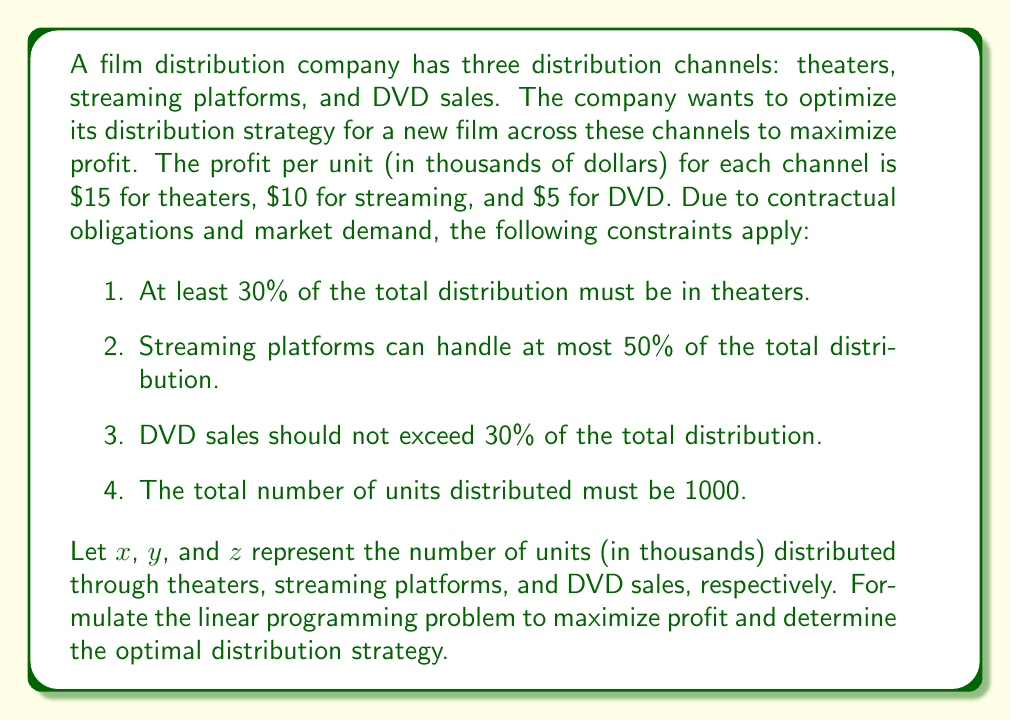Solve this math problem. To solve this problem, we need to set up the linear programming model and then solve it. Let's go through this step-by-step:

1. Define the objective function:
   We want to maximize profit, so our objective function is:
   $$\text{Maximize } P = 15x + 10y + 5z$$

2. Set up the constraints:
   a) Theater constraint: $x \geq 0.3(x + y + z)$
   b) Streaming constraint: $y \leq 0.5(x + y + z)$
   c) DVD constraint: $z \leq 0.3(x + y + z)$
   d) Total distribution: $x + y + z = 1$

3. Simplify the constraints:
   a) $0.7x - 0.3y - 0.3z \geq 0$
   b) $-0.5x + 0.5y - 0.5z \leq 0$
   c) $-0.3x - 0.3y + 0.7z \leq 0$
   d) $x + y + z = 1$

4. Solve the linear programming problem:
   We can solve this using the simplex method or linear programming software. The optimal solution is:
   $x = 0.5$, $y = 0.3$, $z = 0.2$

5. Interpret the results:
   The optimal distribution strategy is:
   - Theaters: 500 units (50%)
   - Streaming platforms: 300 units (30%)
   - DVD sales: 200 units (20%)

6. Calculate the maximum profit:
   $$P = 15(0.5) + 10(0.3) + 5(0.2) = 7.5 + 3 + 1 = 11.5$$

Therefore, the maximum profit is $11.5 million.
Answer: The optimal distribution strategy is 500 units (50%) for theaters, 300 units (30%) for streaming platforms, and 200 units (20%) for DVD sales, yielding a maximum profit of $11.5 million. 